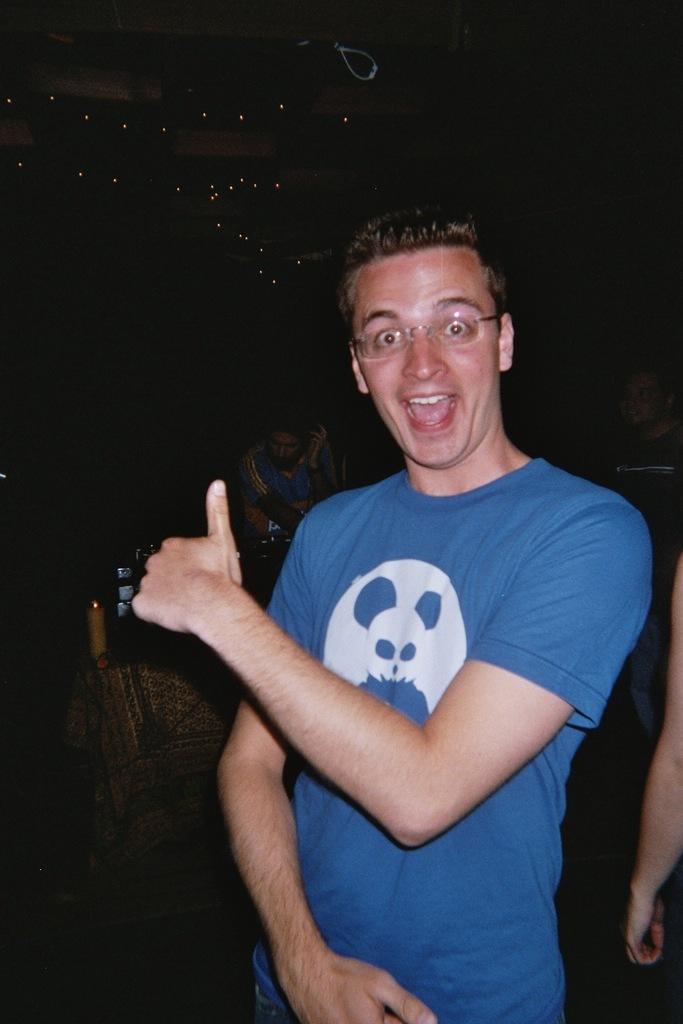Please provide a concise description of this image. In the picture I can see a man. He is wearing a blue color T-shirt and there is a smile on his face. In the background, I can see two men. I can see the hand of a person on the right side. 